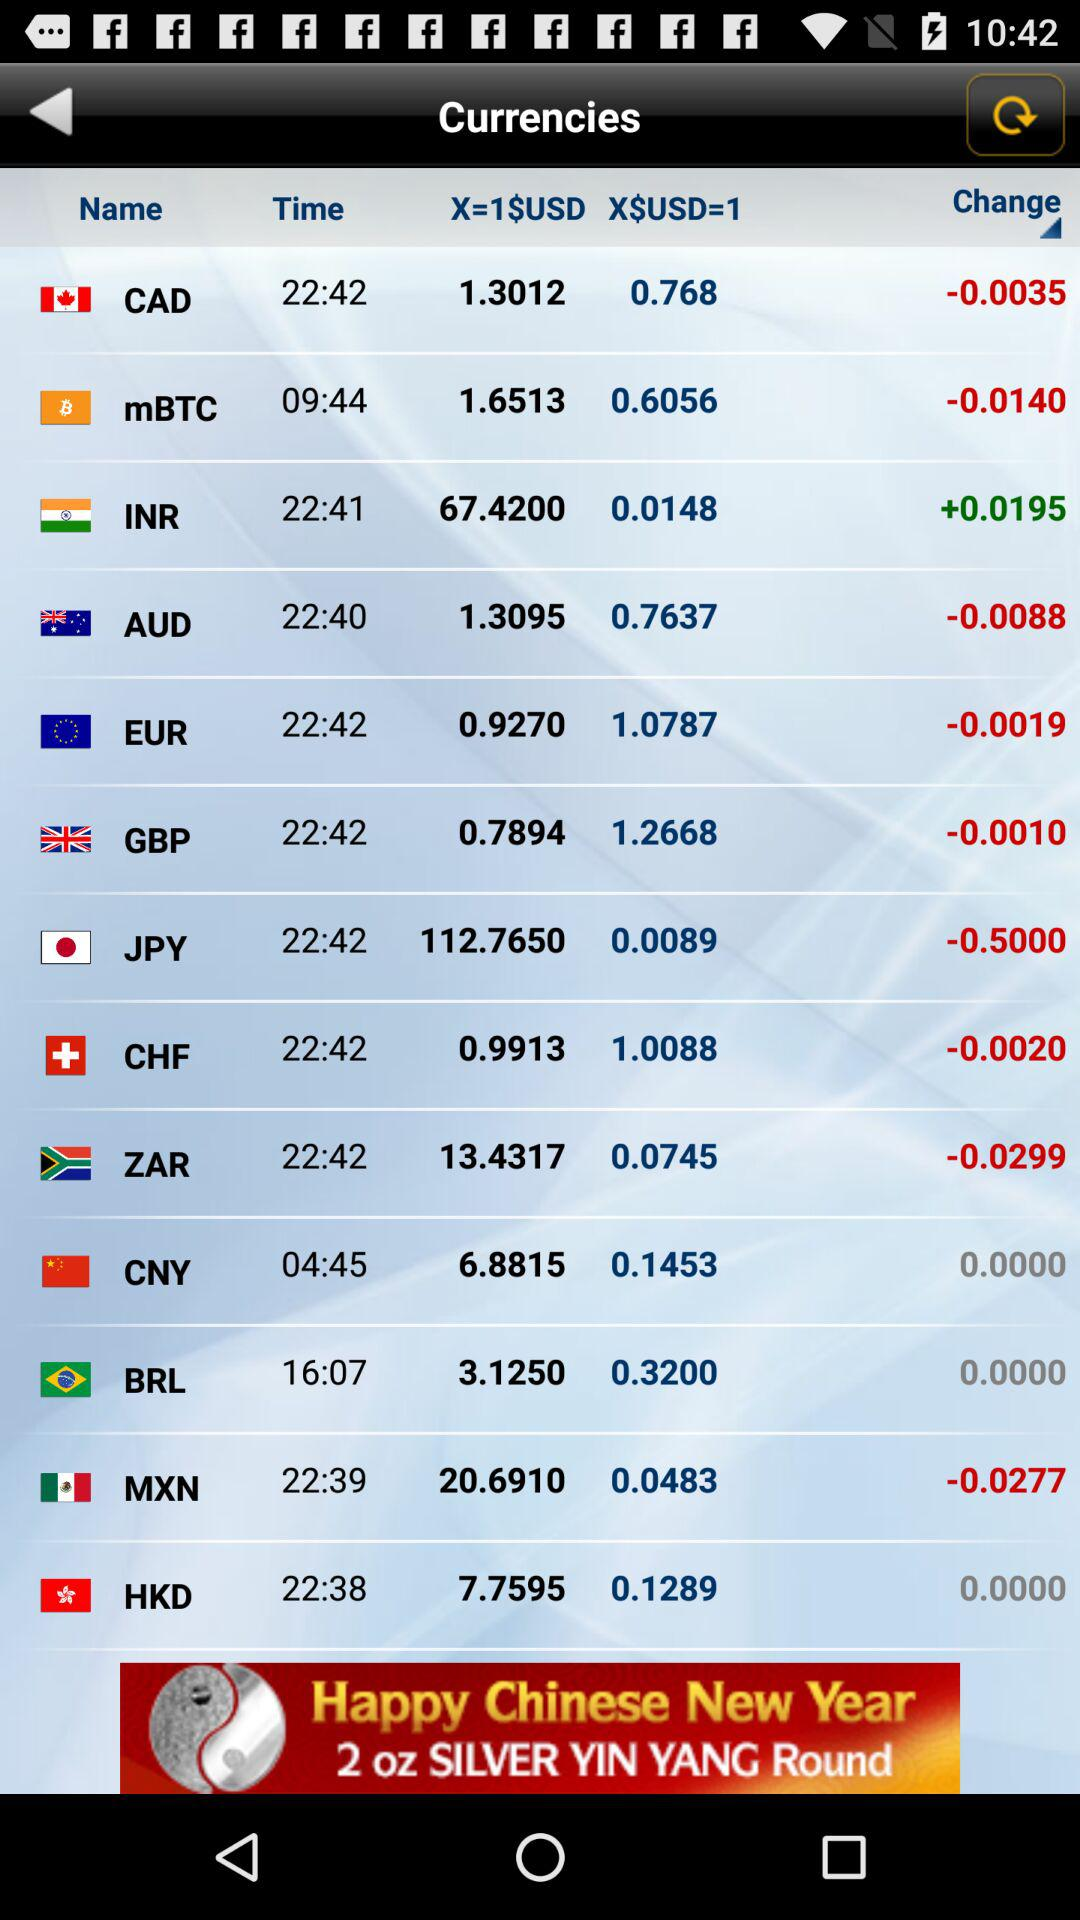What is the result after compare 1 CNY to 1 USD?
When the provided information is insufficient, respond with <no answer>. <no answer> 